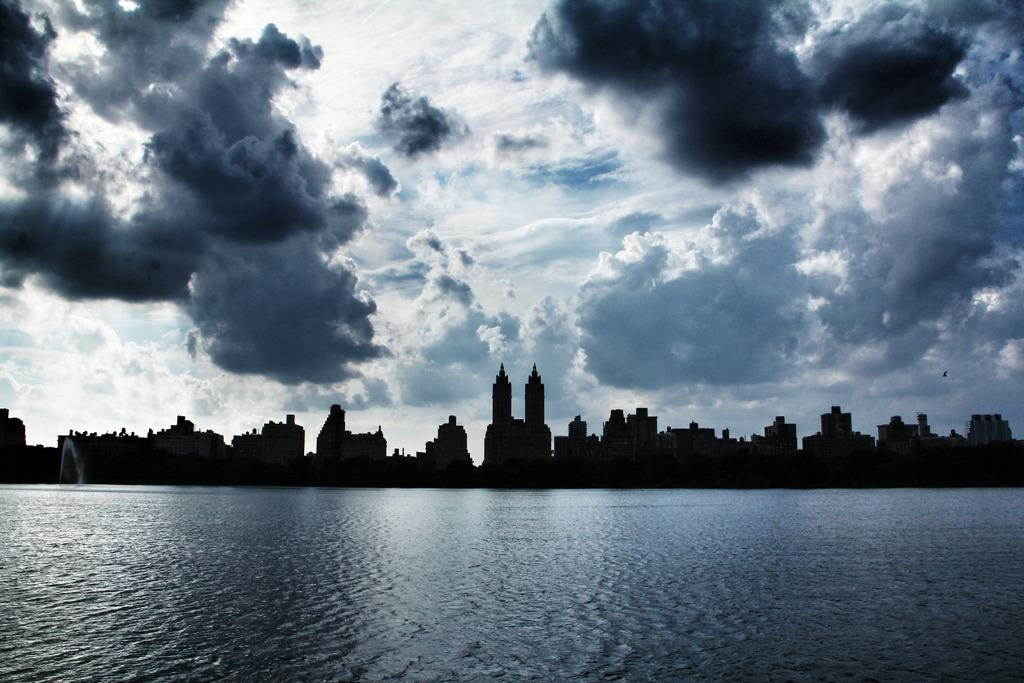What is at the bottom of the image? There is water at the bottom of the image. What can be seen in the distance in the image? There are buildings in the background of the image. What is visible in the sky in the image? The sky is visible in the background of the image. What can be observed in the sky in the image? Clouds are present in the sky. Can you tell me where the pet is located in the image? There is no pet present in the image. What type of copper object can be seen in the image? There is no copper object present in the image. 